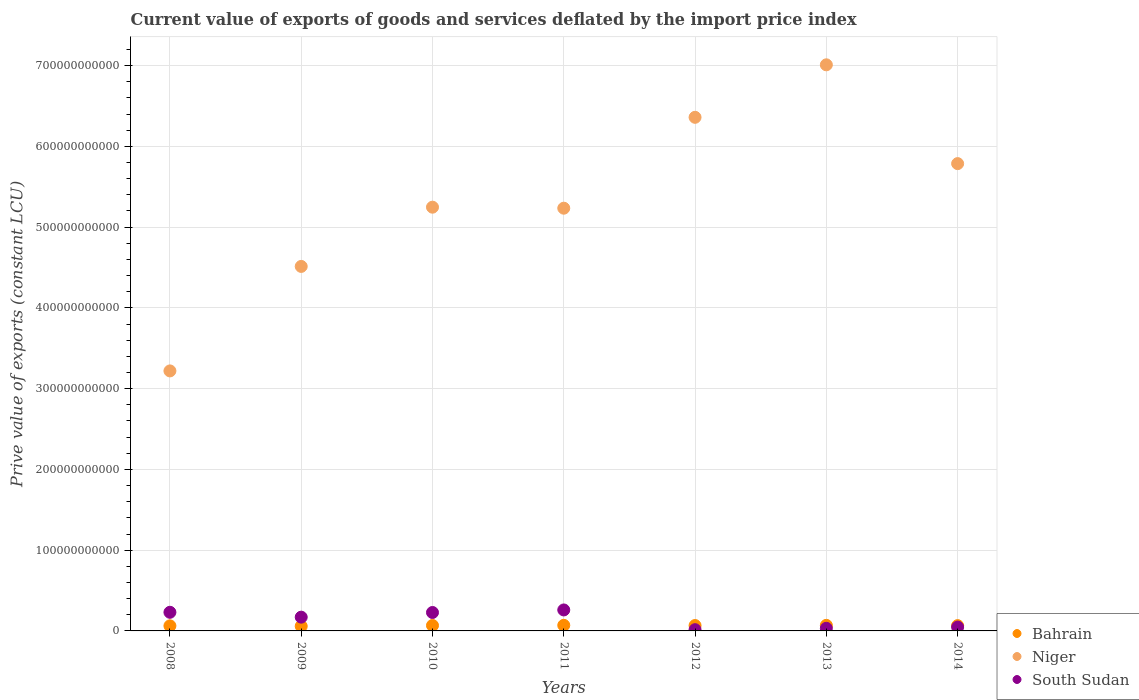Is the number of dotlines equal to the number of legend labels?
Offer a terse response. Yes. What is the prive value of exports in South Sudan in 2013?
Offer a terse response. 3.25e+09. Across all years, what is the maximum prive value of exports in Niger?
Your response must be concise. 7.01e+11. Across all years, what is the minimum prive value of exports in South Sudan?
Make the answer very short. 1.55e+09. In which year was the prive value of exports in South Sudan maximum?
Keep it short and to the point. 2011. In which year was the prive value of exports in Bahrain minimum?
Offer a terse response. 2009. What is the total prive value of exports in Bahrain in the graph?
Your answer should be compact. 4.59e+1. What is the difference between the prive value of exports in Niger in 2012 and that in 2014?
Give a very brief answer. 5.73e+1. What is the difference between the prive value of exports in Niger in 2011 and the prive value of exports in Bahrain in 2010?
Give a very brief answer. 5.17e+11. What is the average prive value of exports in Bahrain per year?
Your response must be concise. 6.56e+09. In the year 2012, what is the difference between the prive value of exports in Bahrain and prive value of exports in South Sudan?
Provide a short and direct response. 5.12e+09. In how many years, is the prive value of exports in Niger greater than 320000000000 LCU?
Keep it short and to the point. 7. What is the ratio of the prive value of exports in Bahrain in 2008 to that in 2011?
Your response must be concise. 0.91. What is the difference between the highest and the second highest prive value of exports in South Sudan?
Give a very brief answer. 2.90e+09. What is the difference between the highest and the lowest prive value of exports in Bahrain?
Offer a terse response. 1.13e+09. In how many years, is the prive value of exports in South Sudan greater than the average prive value of exports in South Sudan taken over all years?
Provide a succinct answer. 4. Is the prive value of exports in Bahrain strictly greater than the prive value of exports in Niger over the years?
Offer a terse response. No. Is the prive value of exports in Niger strictly less than the prive value of exports in South Sudan over the years?
Make the answer very short. No. How many years are there in the graph?
Your response must be concise. 7. What is the difference between two consecutive major ticks on the Y-axis?
Your response must be concise. 1.00e+11. Are the values on the major ticks of Y-axis written in scientific E-notation?
Give a very brief answer. No. Where does the legend appear in the graph?
Ensure brevity in your answer.  Bottom right. What is the title of the graph?
Your answer should be compact. Current value of exports of goods and services deflated by the import price index. What is the label or title of the X-axis?
Give a very brief answer. Years. What is the label or title of the Y-axis?
Make the answer very short. Prive value of exports (constant LCU). What is the Prive value of exports (constant LCU) in Bahrain in 2008?
Your answer should be compact. 6.31e+09. What is the Prive value of exports (constant LCU) in Niger in 2008?
Ensure brevity in your answer.  3.22e+11. What is the Prive value of exports (constant LCU) of South Sudan in 2008?
Offer a terse response. 2.31e+1. What is the Prive value of exports (constant LCU) in Bahrain in 2009?
Provide a succinct answer. 5.81e+09. What is the Prive value of exports (constant LCU) of Niger in 2009?
Make the answer very short. 4.51e+11. What is the Prive value of exports (constant LCU) of South Sudan in 2009?
Give a very brief answer. 1.70e+1. What is the Prive value of exports (constant LCU) in Bahrain in 2010?
Your answer should be compact. 6.72e+09. What is the Prive value of exports (constant LCU) of Niger in 2010?
Ensure brevity in your answer.  5.25e+11. What is the Prive value of exports (constant LCU) of South Sudan in 2010?
Keep it short and to the point. 2.28e+1. What is the Prive value of exports (constant LCU) in Bahrain in 2011?
Your response must be concise. 6.94e+09. What is the Prive value of exports (constant LCU) of Niger in 2011?
Your answer should be very brief. 5.23e+11. What is the Prive value of exports (constant LCU) in South Sudan in 2011?
Offer a terse response. 2.60e+1. What is the Prive value of exports (constant LCU) of Bahrain in 2012?
Your response must be concise. 6.67e+09. What is the Prive value of exports (constant LCU) in Niger in 2012?
Offer a very short reply. 6.36e+11. What is the Prive value of exports (constant LCU) of South Sudan in 2012?
Give a very brief answer. 1.55e+09. What is the Prive value of exports (constant LCU) of Bahrain in 2013?
Offer a terse response. 6.90e+09. What is the Prive value of exports (constant LCU) in Niger in 2013?
Your response must be concise. 7.01e+11. What is the Prive value of exports (constant LCU) of South Sudan in 2013?
Provide a succinct answer. 3.25e+09. What is the Prive value of exports (constant LCU) of Bahrain in 2014?
Your answer should be very brief. 6.56e+09. What is the Prive value of exports (constant LCU) of Niger in 2014?
Offer a terse response. 5.79e+11. What is the Prive value of exports (constant LCU) of South Sudan in 2014?
Offer a terse response. 4.76e+09. Across all years, what is the maximum Prive value of exports (constant LCU) of Bahrain?
Provide a short and direct response. 6.94e+09. Across all years, what is the maximum Prive value of exports (constant LCU) of Niger?
Ensure brevity in your answer.  7.01e+11. Across all years, what is the maximum Prive value of exports (constant LCU) of South Sudan?
Offer a very short reply. 2.60e+1. Across all years, what is the minimum Prive value of exports (constant LCU) of Bahrain?
Make the answer very short. 5.81e+09. Across all years, what is the minimum Prive value of exports (constant LCU) of Niger?
Keep it short and to the point. 3.22e+11. Across all years, what is the minimum Prive value of exports (constant LCU) in South Sudan?
Your answer should be very brief. 1.55e+09. What is the total Prive value of exports (constant LCU) of Bahrain in the graph?
Give a very brief answer. 4.59e+1. What is the total Prive value of exports (constant LCU) of Niger in the graph?
Your answer should be compact. 3.74e+12. What is the total Prive value of exports (constant LCU) of South Sudan in the graph?
Your answer should be compact. 9.85e+1. What is the difference between the Prive value of exports (constant LCU) in Bahrain in 2008 and that in 2009?
Your answer should be compact. 5.00e+08. What is the difference between the Prive value of exports (constant LCU) of Niger in 2008 and that in 2009?
Ensure brevity in your answer.  -1.29e+11. What is the difference between the Prive value of exports (constant LCU) in South Sudan in 2008 and that in 2009?
Your response must be concise. 6.03e+09. What is the difference between the Prive value of exports (constant LCU) in Bahrain in 2008 and that in 2010?
Make the answer very short. -4.17e+08. What is the difference between the Prive value of exports (constant LCU) in Niger in 2008 and that in 2010?
Give a very brief answer. -2.03e+11. What is the difference between the Prive value of exports (constant LCU) of South Sudan in 2008 and that in 2010?
Your answer should be compact. 2.50e+08. What is the difference between the Prive value of exports (constant LCU) in Bahrain in 2008 and that in 2011?
Give a very brief answer. -6.30e+08. What is the difference between the Prive value of exports (constant LCU) in Niger in 2008 and that in 2011?
Provide a succinct answer. -2.01e+11. What is the difference between the Prive value of exports (constant LCU) of South Sudan in 2008 and that in 2011?
Your response must be concise. -2.90e+09. What is the difference between the Prive value of exports (constant LCU) in Bahrain in 2008 and that in 2012?
Offer a very short reply. -3.62e+08. What is the difference between the Prive value of exports (constant LCU) in Niger in 2008 and that in 2012?
Keep it short and to the point. -3.14e+11. What is the difference between the Prive value of exports (constant LCU) of South Sudan in 2008 and that in 2012?
Give a very brief answer. 2.15e+1. What is the difference between the Prive value of exports (constant LCU) of Bahrain in 2008 and that in 2013?
Your response must be concise. -5.91e+08. What is the difference between the Prive value of exports (constant LCU) of Niger in 2008 and that in 2013?
Provide a succinct answer. -3.79e+11. What is the difference between the Prive value of exports (constant LCU) in South Sudan in 2008 and that in 2013?
Offer a very short reply. 1.98e+1. What is the difference between the Prive value of exports (constant LCU) in Bahrain in 2008 and that in 2014?
Offer a very short reply. -2.49e+08. What is the difference between the Prive value of exports (constant LCU) of Niger in 2008 and that in 2014?
Offer a terse response. -2.57e+11. What is the difference between the Prive value of exports (constant LCU) of South Sudan in 2008 and that in 2014?
Make the answer very short. 1.83e+1. What is the difference between the Prive value of exports (constant LCU) of Bahrain in 2009 and that in 2010?
Your answer should be very brief. -9.16e+08. What is the difference between the Prive value of exports (constant LCU) of Niger in 2009 and that in 2010?
Make the answer very short. -7.34e+1. What is the difference between the Prive value of exports (constant LCU) in South Sudan in 2009 and that in 2010?
Your answer should be very brief. -5.78e+09. What is the difference between the Prive value of exports (constant LCU) in Bahrain in 2009 and that in 2011?
Offer a terse response. -1.13e+09. What is the difference between the Prive value of exports (constant LCU) in Niger in 2009 and that in 2011?
Give a very brief answer. -7.21e+1. What is the difference between the Prive value of exports (constant LCU) in South Sudan in 2009 and that in 2011?
Offer a terse response. -8.93e+09. What is the difference between the Prive value of exports (constant LCU) in Bahrain in 2009 and that in 2012?
Make the answer very short. -8.62e+08. What is the difference between the Prive value of exports (constant LCU) in Niger in 2009 and that in 2012?
Provide a succinct answer. -1.85e+11. What is the difference between the Prive value of exports (constant LCU) of South Sudan in 2009 and that in 2012?
Your response must be concise. 1.55e+1. What is the difference between the Prive value of exports (constant LCU) of Bahrain in 2009 and that in 2013?
Offer a terse response. -1.09e+09. What is the difference between the Prive value of exports (constant LCU) in Niger in 2009 and that in 2013?
Keep it short and to the point. -2.50e+11. What is the difference between the Prive value of exports (constant LCU) of South Sudan in 2009 and that in 2013?
Provide a succinct answer. 1.38e+1. What is the difference between the Prive value of exports (constant LCU) in Bahrain in 2009 and that in 2014?
Offer a very short reply. -7.49e+08. What is the difference between the Prive value of exports (constant LCU) of Niger in 2009 and that in 2014?
Your answer should be very brief. -1.27e+11. What is the difference between the Prive value of exports (constant LCU) of South Sudan in 2009 and that in 2014?
Ensure brevity in your answer.  1.23e+1. What is the difference between the Prive value of exports (constant LCU) of Bahrain in 2010 and that in 2011?
Provide a succinct answer. -2.13e+08. What is the difference between the Prive value of exports (constant LCU) in Niger in 2010 and that in 2011?
Make the answer very short. 1.26e+09. What is the difference between the Prive value of exports (constant LCU) in South Sudan in 2010 and that in 2011?
Provide a short and direct response. -3.15e+09. What is the difference between the Prive value of exports (constant LCU) of Bahrain in 2010 and that in 2012?
Provide a succinct answer. 5.46e+07. What is the difference between the Prive value of exports (constant LCU) in Niger in 2010 and that in 2012?
Offer a terse response. -1.11e+11. What is the difference between the Prive value of exports (constant LCU) of South Sudan in 2010 and that in 2012?
Ensure brevity in your answer.  2.13e+1. What is the difference between the Prive value of exports (constant LCU) of Bahrain in 2010 and that in 2013?
Provide a short and direct response. -1.74e+08. What is the difference between the Prive value of exports (constant LCU) of Niger in 2010 and that in 2013?
Ensure brevity in your answer.  -1.76e+11. What is the difference between the Prive value of exports (constant LCU) of South Sudan in 2010 and that in 2013?
Make the answer very short. 1.96e+1. What is the difference between the Prive value of exports (constant LCU) of Bahrain in 2010 and that in 2014?
Provide a short and direct response. 1.67e+08. What is the difference between the Prive value of exports (constant LCU) of Niger in 2010 and that in 2014?
Offer a very short reply. -5.39e+1. What is the difference between the Prive value of exports (constant LCU) in South Sudan in 2010 and that in 2014?
Keep it short and to the point. 1.81e+1. What is the difference between the Prive value of exports (constant LCU) of Bahrain in 2011 and that in 2012?
Give a very brief answer. 2.68e+08. What is the difference between the Prive value of exports (constant LCU) of Niger in 2011 and that in 2012?
Make the answer very short. -1.13e+11. What is the difference between the Prive value of exports (constant LCU) in South Sudan in 2011 and that in 2012?
Your answer should be compact. 2.44e+1. What is the difference between the Prive value of exports (constant LCU) in Bahrain in 2011 and that in 2013?
Offer a terse response. 3.91e+07. What is the difference between the Prive value of exports (constant LCU) in Niger in 2011 and that in 2013?
Offer a very short reply. -1.78e+11. What is the difference between the Prive value of exports (constant LCU) in South Sudan in 2011 and that in 2013?
Your answer should be compact. 2.27e+1. What is the difference between the Prive value of exports (constant LCU) in Bahrain in 2011 and that in 2014?
Give a very brief answer. 3.80e+08. What is the difference between the Prive value of exports (constant LCU) of Niger in 2011 and that in 2014?
Offer a very short reply. -5.52e+1. What is the difference between the Prive value of exports (constant LCU) in South Sudan in 2011 and that in 2014?
Offer a very short reply. 2.12e+1. What is the difference between the Prive value of exports (constant LCU) of Bahrain in 2012 and that in 2013?
Offer a terse response. -2.29e+08. What is the difference between the Prive value of exports (constant LCU) in Niger in 2012 and that in 2013?
Ensure brevity in your answer.  -6.50e+1. What is the difference between the Prive value of exports (constant LCU) of South Sudan in 2012 and that in 2013?
Your answer should be very brief. -1.70e+09. What is the difference between the Prive value of exports (constant LCU) of Bahrain in 2012 and that in 2014?
Make the answer very short. 1.13e+08. What is the difference between the Prive value of exports (constant LCU) in Niger in 2012 and that in 2014?
Give a very brief answer. 5.73e+1. What is the difference between the Prive value of exports (constant LCU) of South Sudan in 2012 and that in 2014?
Keep it short and to the point. -3.22e+09. What is the difference between the Prive value of exports (constant LCU) in Bahrain in 2013 and that in 2014?
Provide a short and direct response. 3.41e+08. What is the difference between the Prive value of exports (constant LCU) of Niger in 2013 and that in 2014?
Ensure brevity in your answer.  1.22e+11. What is the difference between the Prive value of exports (constant LCU) of South Sudan in 2013 and that in 2014?
Your answer should be compact. -1.51e+09. What is the difference between the Prive value of exports (constant LCU) of Bahrain in 2008 and the Prive value of exports (constant LCU) of Niger in 2009?
Make the answer very short. -4.45e+11. What is the difference between the Prive value of exports (constant LCU) in Bahrain in 2008 and the Prive value of exports (constant LCU) in South Sudan in 2009?
Keep it short and to the point. -1.07e+1. What is the difference between the Prive value of exports (constant LCU) in Niger in 2008 and the Prive value of exports (constant LCU) in South Sudan in 2009?
Provide a succinct answer. 3.05e+11. What is the difference between the Prive value of exports (constant LCU) in Bahrain in 2008 and the Prive value of exports (constant LCU) in Niger in 2010?
Make the answer very short. -5.18e+11. What is the difference between the Prive value of exports (constant LCU) in Bahrain in 2008 and the Prive value of exports (constant LCU) in South Sudan in 2010?
Your response must be concise. -1.65e+1. What is the difference between the Prive value of exports (constant LCU) of Niger in 2008 and the Prive value of exports (constant LCU) of South Sudan in 2010?
Give a very brief answer. 2.99e+11. What is the difference between the Prive value of exports (constant LCU) in Bahrain in 2008 and the Prive value of exports (constant LCU) in Niger in 2011?
Keep it short and to the point. -5.17e+11. What is the difference between the Prive value of exports (constant LCU) of Bahrain in 2008 and the Prive value of exports (constant LCU) of South Sudan in 2011?
Your answer should be very brief. -1.97e+1. What is the difference between the Prive value of exports (constant LCU) in Niger in 2008 and the Prive value of exports (constant LCU) in South Sudan in 2011?
Provide a short and direct response. 2.96e+11. What is the difference between the Prive value of exports (constant LCU) of Bahrain in 2008 and the Prive value of exports (constant LCU) of Niger in 2012?
Give a very brief answer. -6.30e+11. What is the difference between the Prive value of exports (constant LCU) in Bahrain in 2008 and the Prive value of exports (constant LCU) in South Sudan in 2012?
Keep it short and to the point. 4.76e+09. What is the difference between the Prive value of exports (constant LCU) in Niger in 2008 and the Prive value of exports (constant LCU) in South Sudan in 2012?
Your answer should be very brief. 3.20e+11. What is the difference between the Prive value of exports (constant LCU) in Bahrain in 2008 and the Prive value of exports (constant LCU) in Niger in 2013?
Keep it short and to the point. -6.95e+11. What is the difference between the Prive value of exports (constant LCU) of Bahrain in 2008 and the Prive value of exports (constant LCU) of South Sudan in 2013?
Your response must be concise. 3.06e+09. What is the difference between the Prive value of exports (constant LCU) of Niger in 2008 and the Prive value of exports (constant LCU) of South Sudan in 2013?
Offer a very short reply. 3.19e+11. What is the difference between the Prive value of exports (constant LCU) in Bahrain in 2008 and the Prive value of exports (constant LCU) in Niger in 2014?
Give a very brief answer. -5.72e+11. What is the difference between the Prive value of exports (constant LCU) in Bahrain in 2008 and the Prive value of exports (constant LCU) in South Sudan in 2014?
Offer a very short reply. 1.54e+09. What is the difference between the Prive value of exports (constant LCU) in Niger in 2008 and the Prive value of exports (constant LCU) in South Sudan in 2014?
Provide a short and direct response. 3.17e+11. What is the difference between the Prive value of exports (constant LCU) of Bahrain in 2009 and the Prive value of exports (constant LCU) of Niger in 2010?
Make the answer very short. -5.19e+11. What is the difference between the Prive value of exports (constant LCU) in Bahrain in 2009 and the Prive value of exports (constant LCU) in South Sudan in 2010?
Give a very brief answer. -1.70e+1. What is the difference between the Prive value of exports (constant LCU) in Niger in 2009 and the Prive value of exports (constant LCU) in South Sudan in 2010?
Make the answer very short. 4.28e+11. What is the difference between the Prive value of exports (constant LCU) in Bahrain in 2009 and the Prive value of exports (constant LCU) in Niger in 2011?
Provide a succinct answer. -5.18e+11. What is the difference between the Prive value of exports (constant LCU) in Bahrain in 2009 and the Prive value of exports (constant LCU) in South Sudan in 2011?
Ensure brevity in your answer.  -2.02e+1. What is the difference between the Prive value of exports (constant LCU) in Niger in 2009 and the Prive value of exports (constant LCU) in South Sudan in 2011?
Offer a terse response. 4.25e+11. What is the difference between the Prive value of exports (constant LCU) of Bahrain in 2009 and the Prive value of exports (constant LCU) of Niger in 2012?
Provide a short and direct response. -6.30e+11. What is the difference between the Prive value of exports (constant LCU) in Bahrain in 2009 and the Prive value of exports (constant LCU) in South Sudan in 2012?
Offer a terse response. 4.26e+09. What is the difference between the Prive value of exports (constant LCU) in Niger in 2009 and the Prive value of exports (constant LCU) in South Sudan in 2012?
Provide a succinct answer. 4.50e+11. What is the difference between the Prive value of exports (constant LCU) in Bahrain in 2009 and the Prive value of exports (constant LCU) in Niger in 2013?
Offer a terse response. -6.95e+11. What is the difference between the Prive value of exports (constant LCU) of Bahrain in 2009 and the Prive value of exports (constant LCU) of South Sudan in 2013?
Offer a terse response. 2.56e+09. What is the difference between the Prive value of exports (constant LCU) of Niger in 2009 and the Prive value of exports (constant LCU) of South Sudan in 2013?
Ensure brevity in your answer.  4.48e+11. What is the difference between the Prive value of exports (constant LCU) in Bahrain in 2009 and the Prive value of exports (constant LCU) in Niger in 2014?
Your answer should be compact. -5.73e+11. What is the difference between the Prive value of exports (constant LCU) in Bahrain in 2009 and the Prive value of exports (constant LCU) in South Sudan in 2014?
Provide a short and direct response. 1.05e+09. What is the difference between the Prive value of exports (constant LCU) in Niger in 2009 and the Prive value of exports (constant LCU) in South Sudan in 2014?
Your answer should be compact. 4.47e+11. What is the difference between the Prive value of exports (constant LCU) of Bahrain in 2010 and the Prive value of exports (constant LCU) of Niger in 2011?
Offer a terse response. -5.17e+11. What is the difference between the Prive value of exports (constant LCU) in Bahrain in 2010 and the Prive value of exports (constant LCU) in South Sudan in 2011?
Offer a terse response. -1.92e+1. What is the difference between the Prive value of exports (constant LCU) of Niger in 2010 and the Prive value of exports (constant LCU) of South Sudan in 2011?
Your answer should be compact. 4.99e+11. What is the difference between the Prive value of exports (constant LCU) in Bahrain in 2010 and the Prive value of exports (constant LCU) in Niger in 2012?
Offer a terse response. -6.29e+11. What is the difference between the Prive value of exports (constant LCU) of Bahrain in 2010 and the Prive value of exports (constant LCU) of South Sudan in 2012?
Provide a succinct answer. 5.18e+09. What is the difference between the Prive value of exports (constant LCU) of Niger in 2010 and the Prive value of exports (constant LCU) of South Sudan in 2012?
Keep it short and to the point. 5.23e+11. What is the difference between the Prive value of exports (constant LCU) in Bahrain in 2010 and the Prive value of exports (constant LCU) in Niger in 2013?
Make the answer very short. -6.94e+11. What is the difference between the Prive value of exports (constant LCU) of Bahrain in 2010 and the Prive value of exports (constant LCU) of South Sudan in 2013?
Provide a short and direct response. 3.48e+09. What is the difference between the Prive value of exports (constant LCU) of Niger in 2010 and the Prive value of exports (constant LCU) of South Sudan in 2013?
Your response must be concise. 5.21e+11. What is the difference between the Prive value of exports (constant LCU) in Bahrain in 2010 and the Prive value of exports (constant LCU) in Niger in 2014?
Give a very brief answer. -5.72e+11. What is the difference between the Prive value of exports (constant LCU) of Bahrain in 2010 and the Prive value of exports (constant LCU) of South Sudan in 2014?
Give a very brief answer. 1.96e+09. What is the difference between the Prive value of exports (constant LCU) in Niger in 2010 and the Prive value of exports (constant LCU) in South Sudan in 2014?
Your answer should be compact. 5.20e+11. What is the difference between the Prive value of exports (constant LCU) in Bahrain in 2011 and the Prive value of exports (constant LCU) in Niger in 2012?
Your answer should be very brief. -6.29e+11. What is the difference between the Prive value of exports (constant LCU) in Bahrain in 2011 and the Prive value of exports (constant LCU) in South Sudan in 2012?
Ensure brevity in your answer.  5.39e+09. What is the difference between the Prive value of exports (constant LCU) in Niger in 2011 and the Prive value of exports (constant LCU) in South Sudan in 2012?
Your answer should be very brief. 5.22e+11. What is the difference between the Prive value of exports (constant LCU) in Bahrain in 2011 and the Prive value of exports (constant LCU) in Niger in 2013?
Provide a short and direct response. -6.94e+11. What is the difference between the Prive value of exports (constant LCU) in Bahrain in 2011 and the Prive value of exports (constant LCU) in South Sudan in 2013?
Your response must be concise. 3.69e+09. What is the difference between the Prive value of exports (constant LCU) in Niger in 2011 and the Prive value of exports (constant LCU) in South Sudan in 2013?
Keep it short and to the point. 5.20e+11. What is the difference between the Prive value of exports (constant LCU) of Bahrain in 2011 and the Prive value of exports (constant LCU) of Niger in 2014?
Provide a succinct answer. -5.72e+11. What is the difference between the Prive value of exports (constant LCU) of Bahrain in 2011 and the Prive value of exports (constant LCU) of South Sudan in 2014?
Make the answer very short. 2.17e+09. What is the difference between the Prive value of exports (constant LCU) of Niger in 2011 and the Prive value of exports (constant LCU) of South Sudan in 2014?
Offer a very short reply. 5.19e+11. What is the difference between the Prive value of exports (constant LCU) in Bahrain in 2012 and the Prive value of exports (constant LCU) in Niger in 2013?
Make the answer very short. -6.94e+11. What is the difference between the Prive value of exports (constant LCU) of Bahrain in 2012 and the Prive value of exports (constant LCU) of South Sudan in 2013?
Keep it short and to the point. 3.42e+09. What is the difference between the Prive value of exports (constant LCU) of Niger in 2012 and the Prive value of exports (constant LCU) of South Sudan in 2013?
Provide a succinct answer. 6.33e+11. What is the difference between the Prive value of exports (constant LCU) in Bahrain in 2012 and the Prive value of exports (constant LCU) in Niger in 2014?
Offer a very short reply. -5.72e+11. What is the difference between the Prive value of exports (constant LCU) in Bahrain in 2012 and the Prive value of exports (constant LCU) in South Sudan in 2014?
Provide a succinct answer. 1.91e+09. What is the difference between the Prive value of exports (constant LCU) in Niger in 2012 and the Prive value of exports (constant LCU) in South Sudan in 2014?
Keep it short and to the point. 6.31e+11. What is the difference between the Prive value of exports (constant LCU) in Bahrain in 2013 and the Prive value of exports (constant LCU) in Niger in 2014?
Provide a short and direct response. -5.72e+11. What is the difference between the Prive value of exports (constant LCU) of Bahrain in 2013 and the Prive value of exports (constant LCU) of South Sudan in 2014?
Ensure brevity in your answer.  2.14e+09. What is the difference between the Prive value of exports (constant LCU) of Niger in 2013 and the Prive value of exports (constant LCU) of South Sudan in 2014?
Offer a terse response. 6.96e+11. What is the average Prive value of exports (constant LCU) in Bahrain per year?
Give a very brief answer. 6.56e+09. What is the average Prive value of exports (constant LCU) in Niger per year?
Your answer should be compact. 5.34e+11. What is the average Prive value of exports (constant LCU) in South Sudan per year?
Provide a short and direct response. 1.41e+1. In the year 2008, what is the difference between the Prive value of exports (constant LCU) of Bahrain and Prive value of exports (constant LCU) of Niger?
Your answer should be compact. -3.16e+11. In the year 2008, what is the difference between the Prive value of exports (constant LCU) in Bahrain and Prive value of exports (constant LCU) in South Sudan?
Give a very brief answer. -1.68e+1. In the year 2008, what is the difference between the Prive value of exports (constant LCU) of Niger and Prive value of exports (constant LCU) of South Sudan?
Make the answer very short. 2.99e+11. In the year 2009, what is the difference between the Prive value of exports (constant LCU) in Bahrain and Prive value of exports (constant LCU) in Niger?
Ensure brevity in your answer.  -4.45e+11. In the year 2009, what is the difference between the Prive value of exports (constant LCU) in Bahrain and Prive value of exports (constant LCU) in South Sudan?
Give a very brief answer. -1.12e+1. In the year 2009, what is the difference between the Prive value of exports (constant LCU) of Niger and Prive value of exports (constant LCU) of South Sudan?
Your answer should be very brief. 4.34e+11. In the year 2010, what is the difference between the Prive value of exports (constant LCU) of Bahrain and Prive value of exports (constant LCU) of Niger?
Your response must be concise. -5.18e+11. In the year 2010, what is the difference between the Prive value of exports (constant LCU) in Bahrain and Prive value of exports (constant LCU) in South Sudan?
Your response must be concise. -1.61e+1. In the year 2010, what is the difference between the Prive value of exports (constant LCU) of Niger and Prive value of exports (constant LCU) of South Sudan?
Your answer should be compact. 5.02e+11. In the year 2011, what is the difference between the Prive value of exports (constant LCU) of Bahrain and Prive value of exports (constant LCU) of Niger?
Provide a short and direct response. -5.16e+11. In the year 2011, what is the difference between the Prive value of exports (constant LCU) in Bahrain and Prive value of exports (constant LCU) in South Sudan?
Your answer should be very brief. -1.90e+1. In the year 2011, what is the difference between the Prive value of exports (constant LCU) of Niger and Prive value of exports (constant LCU) of South Sudan?
Offer a terse response. 4.97e+11. In the year 2012, what is the difference between the Prive value of exports (constant LCU) in Bahrain and Prive value of exports (constant LCU) in Niger?
Provide a succinct answer. -6.29e+11. In the year 2012, what is the difference between the Prive value of exports (constant LCU) in Bahrain and Prive value of exports (constant LCU) in South Sudan?
Make the answer very short. 5.12e+09. In the year 2012, what is the difference between the Prive value of exports (constant LCU) in Niger and Prive value of exports (constant LCU) in South Sudan?
Give a very brief answer. 6.34e+11. In the year 2013, what is the difference between the Prive value of exports (constant LCU) in Bahrain and Prive value of exports (constant LCU) in Niger?
Give a very brief answer. -6.94e+11. In the year 2013, what is the difference between the Prive value of exports (constant LCU) in Bahrain and Prive value of exports (constant LCU) in South Sudan?
Your answer should be very brief. 3.65e+09. In the year 2013, what is the difference between the Prive value of exports (constant LCU) of Niger and Prive value of exports (constant LCU) of South Sudan?
Offer a terse response. 6.98e+11. In the year 2014, what is the difference between the Prive value of exports (constant LCU) of Bahrain and Prive value of exports (constant LCU) of Niger?
Give a very brief answer. -5.72e+11. In the year 2014, what is the difference between the Prive value of exports (constant LCU) in Bahrain and Prive value of exports (constant LCU) in South Sudan?
Your answer should be compact. 1.79e+09. In the year 2014, what is the difference between the Prive value of exports (constant LCU) in Niger and Prive value of exports (constant LCU) in South Sudan?
Your answer should be compact. 5.74e+11. What is the ratio of the Prive value of exports (constant LCU) of Bahrain in 2008 to that in 2009?
Make the answer very short. 1.09. What is the ratio of the Prive value of exports (constant LCU) in Niger in 2008 to that in 2009?
Keep it short and to the point. 0.71. What is the ratio of the Prive value of exports (constant LCU) of South Sudan in 2008 to that in 2009?
Provide a succinct answer. 1.35. What is the ratio of the Prive value of exports (constant LCU) of Bahrain in 2008 to that in 2010?
Ensure brevity in your answer.  0.94. What is the ratio of the Prive value of exports (constant LCU) in Niger in 2008 to that in 2010?
Provide a succinct answer. 0.61. What is the ratio of the Prive value of exports (constant LCU) of Bahrain in 2008 to that in 2011?
Make the answer very short. 0.91. What is the ratio of the Prive value of exports (constant LCU) of Niger in 2008 to that in 2011?
Keep it short and to the point. 0.62. What is the ratio of the Prive value of exports (constant LCU) in South Sudan in 2008 to that in 2011?
Your answer should be very brief. 0.89. What is the ratio of the Prive value of exports (constant LCU) in Bahrain in 2008 to that in 2012?
Your answer should be very brief. 0.95. What is the ratio of the Prive value of exports (constant LCU) in Niger in 2008 to that in 2012?
Your response must be concise. 0.51. What is the ratio of the Prive value of exports (constant LCU) of South Sudan in 2008 to that in 2012?
Your response must be concise. 14.93. What is the ratio of the Prive value of exports (constant LCU) of Bahrain in 2008 to that in 2013?
Provide a succinct answer. 0.91. What is the ratio of the Prive value of exports (constant LCU) in Niger in 2008 to that in 2013?
Your answer should be very brief. 0.46. What is the ratio of the Prive value of exports (constant LCU) in South Sudan in 2008 to that in 2013?
Offer a terse response. 7.1. What is the ratio of the Prive value of exports (constant LCU) of Bahrain in 2008 to that in 2014?
Your response must be concise. 0.96. What is the ratio of the Prive value of exports (constant LCU) of Niger in 2008 to that in 2014?
Offer a very short reply. 0.56. What is the ratio of the Prive value of exports (constant LCU) of South Sudan in 2008 to that in 2014?
Make the answer very short. 4.84. What is the ratio of the Prive value of exports (constant LCU) of Bahrain in 2009 to that in 2010?
Your answer should be compact. 0.86. What is the ratio of the Prive value of exports (constant LCU) in Niger in 2009 to that in 2010?
Give a very brief answer. 0.86. What is the ratio of the Prive value of exports (constant LCU) in South Sudan in 2009 to that in 2010?
Your answer should be compact. 0.75. What is the ratio of the Prive value of exports (constant LCU) in Bahrain in 2009 to that in 2011?
Make the answer very short. 0.84. What is the ratio of the Prive value of exports (constant LCU) in Niger in 2009 to that in 2011?
Give a very brief answer. 0.86. What is the ratio of the Prive value of exports (constant LCU) in South Sudan in 2009 to that in 2011?
Provide a short and direct response. 0.66. What is the ratio of the Prive value of exports (constant LCU) of Bahrain in 2009 to that in 2012?
Your answer should be compact. 0.87. What is the ratio of the Prive value of exports (constant LCU) of Niger in 2009 to that in 2012?
Your answer should be very brief. 0.71. What is the ratio of the Prive value of exports (constant LCU) in South Sudan in 2009 to that in 2012?
Ensure brevity in your answer.  11.03. What is the ratio of the Prive value of exports (constant LCU) in Bahrain in 2009 to that in 2013?
Offer a very short reply. 0.84. What is the ratio of the Prive value of exports (constant LCU) of Niger in 2009 to that in 2013?
Your answer should be compact. 0.64. What is the ratio of the Prive value of exports (constant LCU) of South Sudan in 2009 to that in 2013?
Your answer should be compact. 5.25. What is the ratio of the Prive value of exports (constant LCU) in Bahrain in 2009 to that in 2014?
Keep it short and to the point. 0.89. What is the ratio of the Prive value of exports (constant LCU) of Niger in 2009 to that in 2014?
Offer a very short reply. 0.78. What is the ratio of the Prive value of exports (constant LCU) in South Sudan in 2009 to that in 2014?
Provide a short and direct response. 3.58. What is the ratio of the Prive value of exports (constant LCU) in Bahrain in 2010 to that in 2011?
Provide a short and direct response. 0.97. What is the ratio of the Prive value of exports (constant LCU) in South Sudan in 2010 to that in 2011?
Keep it short and to the point. 0.88. What is the ratio of the Prive value of exports (constant LCU) of Bahrain in 2010 to that in 2012?
Your response must be concise. 1.01. What is the ratio of the Prive value of exports (constant LCU) in Niger in 2010 to that in 2012?
Provide a short and direct response. 0.82. What is the ratio of the Prive value of exports (constant LCU) in South Sudan in 2010 to that in 2012?
Offer a very short reply. 14.77. What is the ratio of the Prive value of exports (constant LCU) in Bahrain in 2010 to that in 2013?
Your answer should be very brief. 0.97. What is the ratio of the Prive value of exports (constant LCU) of Niger in 2010 to that in 2013?
Give a very brief answer. 0.75. What is the ratio of the Prive value of exports (constant LCU) of South Sudan in 2010 to that in 2013?
Your response must be concise. 7.03. What is the ratio of the Prive value of exports (constant LCU) in Bahrain in 2010 to that in 2014?
Make the answer very short. 1.03. What is the ratio of the Prive value of exports (constant LCU) in Niger in 2010 to that in 2014?
Ensure brevity in your answer.  0.91. What is the ratio of the Prive value of exports (constant LCU) in South Sudan in 2010 to that in 2014?
Offer a terse response. 4.79. What is the ratio of the Prive value of exports (constant LCU) in Bahrain in 2011 to that in 2012?
Your answer should be compact. 1.04. What is the ratio of the Prive value of exports (constant LCU) of Niger in 2011 to that in 2012?
Provide a short and direct response. 0.82. What is the ratio of the Prive value of exports (constant LCU) of South Sudan in 2011 to that in 2012?
Make the answer very short. 16.81. What is the ratio of the Prive value of exports (constant LCU) in Bahrain in 2011 to that in 2013?
Keep it short and to the point. 1.01. What is the ratio of the Prive value of exports (constant LCU) in Niger in 2011 to that in 2013?
Your response must be concise. 0.75. What is the ratio of the Prive value of exports (constant LCU) of South Sudan in 2011 to that in 2013?
Offer a very short reply. 8. What is the ratio of the Prive value of exports (constant LCU) of Bahrain in 2011 to that in 2014?
Offer a very short reply. 1.06. What is the ratio of the Prive value of exports (constant LCU) in Niger in 2011 to that in 2014?
Give a very brief answer. 0.9. What is the ratio of the Prive value of exports (constant LCU) in South Sudan in 2011 to that in 2014?
Provide a short and direct response. 5.45. What is the ratio of the Prive value of exports (constant LCU) of Bahrain in 2012 to that in 2013?
Your response must be concise. 0.97. What is the ratio of the Prive value of exports (constant LCU) of Niger in 2012 to that in 2013?
Provide a short and direct response. 0.91. What is the ratio of the Prive value of exports (constant LCU) of South Sudan in 2012 to that in 2013?
Ensure brevity in your answer.  0.48. What is the ratio of the Prive value of exports (constant LCU) of Bahrain in 2012 to that in 2014?
Your answer should be very brief. 1.02. What is the ratio of the Prive value of exports (constant LCU) in Niger in 2012 to that in 2014?
Ensure brevity in your answer.  1.1. What is the ratio of the Prive value of exports (constant LCU) in South Sudan in 2012 to that in 2014?
Provide a short and direct response. 0.32. What is the ratio of the Prive value of exports (constant LCU) of Bahrain in 2013 to that in 2014?
Offer a terse response. 1.05. What is the ratio of the Prive value of exports (constant LCU) in Niger in 2013 to that in 2014?
Give a very brief answer. 1.21. What is the ratio of the Prive value of exports (constant LCU) of South Sudan in 2013 to that in 2014?
Provide a succinct answer. 0.68. What is the difference between the highest and the second highest Prive value of exports (constant LCU) of Bahrain?
Your answer should be compact. 3.91e+07. What is the difference between the highest and the second highest Prive value of exports (constant LCU) in Niger?
Your response must be concise. 6.50e+1. What is the difference between the highest and the second highest Prive value of exports (constant LCU) of South Sudan?
Make the answer very short. 2.90e+09. What is the difference between the highest and the lowest Prive value of exports (constant LCU) of Bahrain?
Your answer should be compact. 1.13e+09. What is the difference between the highest and the lowest Prive value of exports (constant LCU) of Niger?
Provide a succinct answer. 3.79e+11. What is the difference between the highest and the lowest Prive value of exports (constant LCU) of South Sudan?
Your answer should be compact. 2.44e+1. 